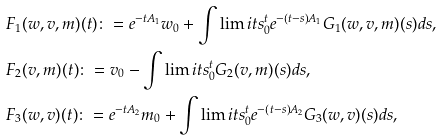<formula> <loc_0><loc_0><loc_500><loc_500>& F _ { 1 } ( w , v , m ) ( t ) \colon = e ^ { - t A _ { 1 } } w _ { 0 } + \int \lim i t s _ { 0 } ^ { t } e ^ { - \left ( t - s \right ) A _ { 1 } } G _ { 1 } ( w , v , m ) ( s ) d s , \\ & F _ { 2 } ( v , m ) ( t ) \colon = v _ { 0 } - \int \lim i t s _ { 0 } ^ { t } G _ { 2 } ( v , m ) ( s ) d s , \\ & F _ { 3 } ( w , v ) ( t ) \colon = e ^ { - t A _ { 2 } } m _ { 0 } + \int \lim i t s _ { 0 } ^ { t } e ^ { - \left ( t - s \right ) A _ { 2 } } G _ { 3 } ( w , v ) ( s ) d s ,</formula> 